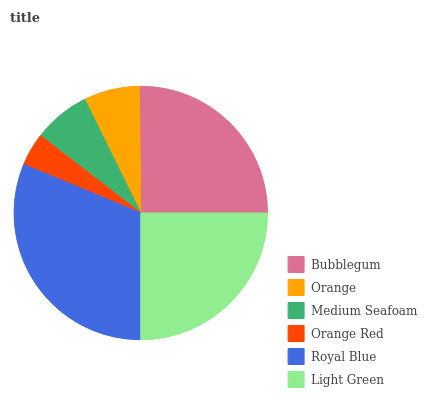Is Orange Red the minimum?
Answer yes or no. Yes. Is Royal Blue the maximum?
Answer yes or no. Yes. Is Orange the minimum?
Answer yes or no. No. Is Orange the maximum?
Answer yes or no. No. Is Bubblegum greater than Orange?
Answer yes or no. Yes. Is Orange less than Bubblegum?
Answer yes or no. Yes. Is Orange greater than Bubblegum?
Answer yes or no. No. Is Bubblegum less than Orange?
Answer yes or no. No. Is Light Green the high median?
Answer yes or no. Yes. Is Medium Seafoam the low median?
Answer yes or no. Yes. Is Royal Blue the high median?
Answer yes or no. No. Is Royal Blue the low median?
Answer yes or no. No. 